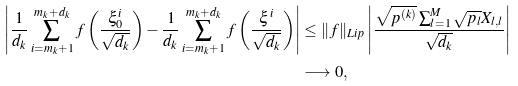<formula> <loc_0><loc_0><loc_500><loc_500>\left | \frac { 1 } { d _ { k } } \sum _ { i = m _ { k } + 1 } ^ { m _ { k } + d _ { k } } f \left ( \frac { \xi _ { 0 } ^ { i } } { \sqrt { d _ { k } } } \right ) - \frac { 1 } { d _ { k } } \sum _ { i = m _ { k } + 1 } ^ { m _ { k } + d _ { k } } f \left ( \frac { \xi ^ { i } } { \sqrt { d _ { k } } } \right ) \right | & \leq \| f \| _ { L i p } \left | \frac { \sqrt { p ^ { ( k ) } } \sum _ { l = 1 } ^ { M } \sqrt { p _ { l } } { X } _ { l , l } } { \sqrt { d _ { k } } } \right | \\ & \longrightarrow 0 ,</formula> 